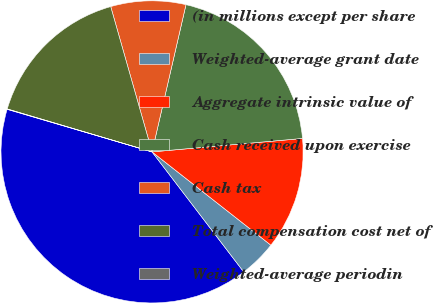Convert chart to OTSL. <chart><loc_0><loc_0><loc_500><loc_500><pie_chart><fcel>(in millions except per share<fcel>Weighted-average grant date<fcel>Aggregate intrinsic value of<fcel>Cash received upon exercise<fcel>Cash tax<fcel>Total compensation cost net of<fcel>Weighted-average periodin<nl><fcel>39.93%<fcel>4.03%<fcel>12.01%<fcel>19.98%<fcel>8.02%<fcel>16.0%<fcel>0.04%<nl></chart> 